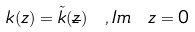Convert formula to latex. <formula><loc_0><loc_0><loc_500><loc_500>k ( z ) = \tilde { k } ( \overline { z } ) \ , I m \ z = 0</formula> 